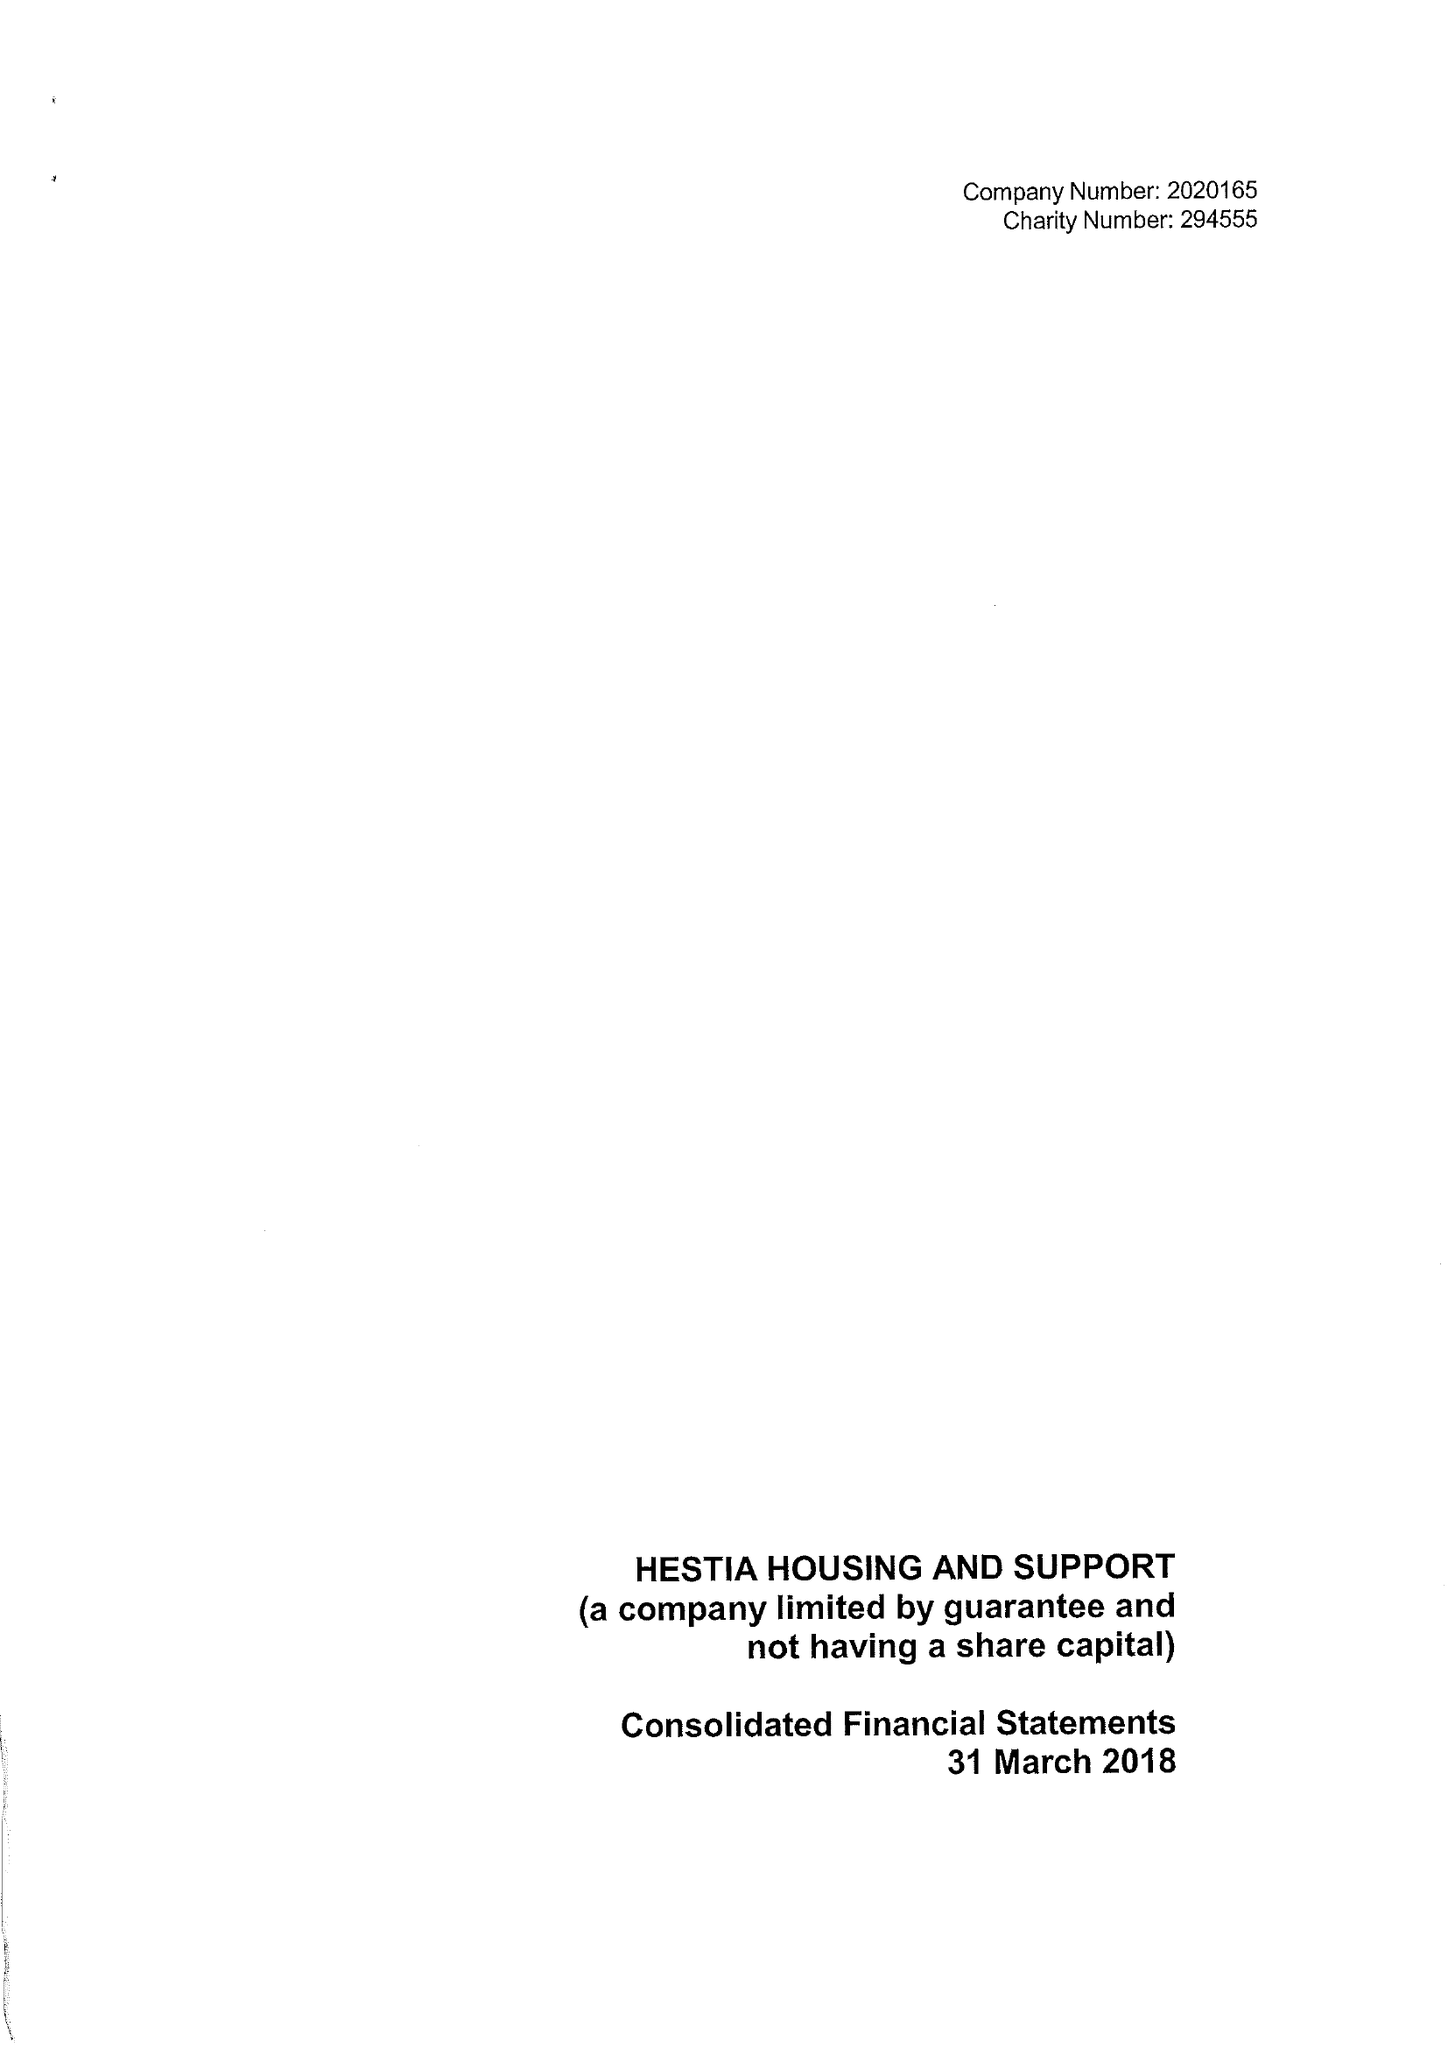What is the value for the charity_number?
Answer the question using a single word or phrase. 294555 